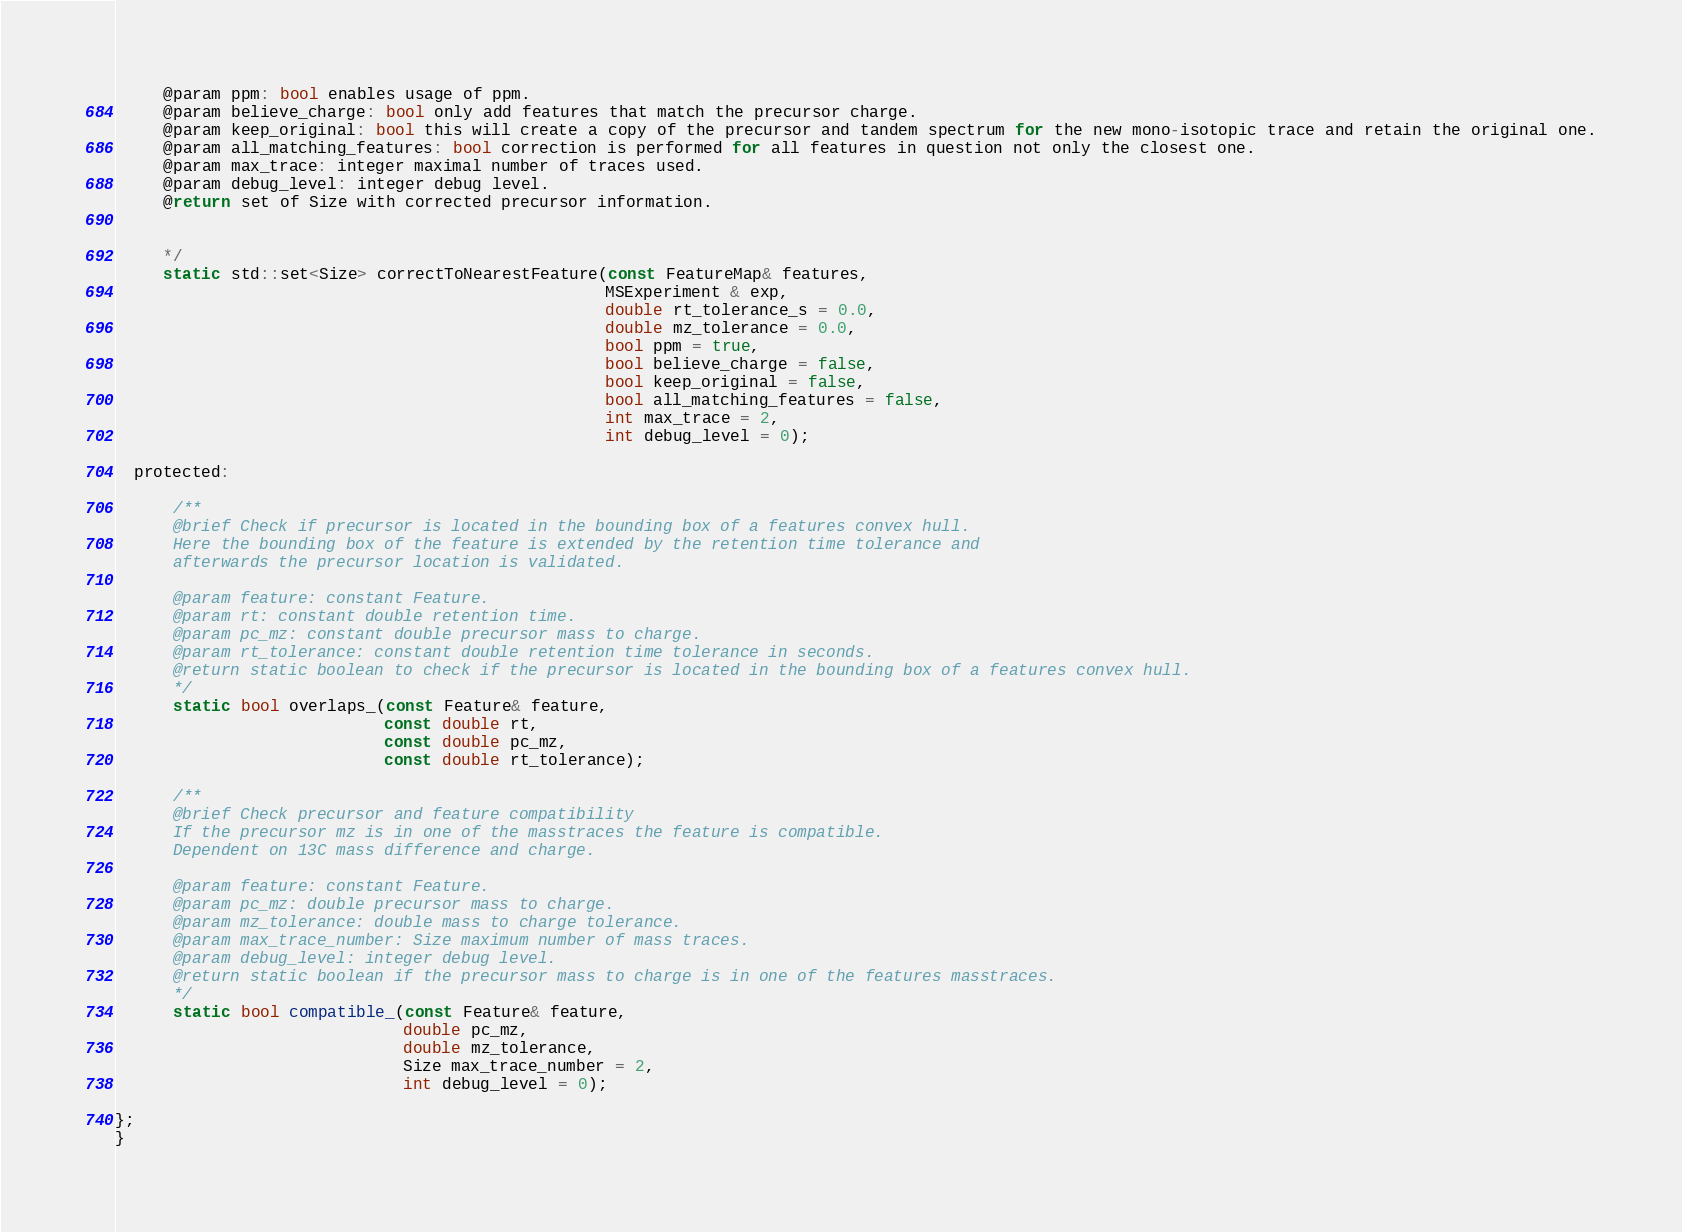<code> <loc_0><loc_0><loc_500><loc_500><_C_>     @param ppm: bool enables usage of ppm.
     @param believe_charge: bool only add features that match the precursor charge.
     @param keep_original: bool this will create a copy of the precursor and tandem spectrum for the new mono-isotopic trace and retain the original one.
     @param all_matching_features: bool correction is performed for all features in question not only the closest one.
     @param max_trace: integer maximal number of traces used.
     @param debug_level: integer debug level.
     @return set of Size with corrected precursor information.


     */
     static std::set<Size> correctToNearestFeature(const FeatureMap& features,
                                                   MSExperiment & exp,
                                                   double rt_tolerance_s = 0.0,
                                                   double mz_tolerance = 0.0,
                                                   bool ppm = true,
                                                   bool believe_charge = false,
                                                   bool keep_original = false,
                                                   bool all_matching_features = false,
                                                   int max_trace = 2,
                                                   int debug_level = 0);

  protected:

      /**
      @brief Check if precursor is located in the bounding box of a features convex hull.
      Here the bounding box of the feature is extended by the retention time tolerance and
      afterwards the precursor location is validated.

      @param feature: constant Feature.
      @param rt: constant double retention time.
      @param pc_mz: constant double precursor mass to charge.
      @param rt_tolerance: constant double retention time tolerance in seconds.
      @return static boolean to check if the precursor is located in the bounding box of a features convex hull.
      */
      static bool overlaps_(const Feature& feature,
                            const double rt,
                            const double pc_mz,
                            const double rt_tolerance);

      /**
      @brief Check precursor and feature compatibility
      If the precursor mz is in one of the masstraces the feature is compatible.
      Dependent on 13C mass difference and charge.

      @param feature: constant Feature.
      @param pc_mz: double precursor mass to charge.
      @param mz_tolerance: double mass to charge tolerance.
      @param max_trace_number: Size maximum number of mass traces.
      @param debug_level: integer debug level.
      @return static boolean if the precursor mass to charge is in one of the features masstraces.
      */
      static bool compatible_(const Feature& feature,
                              double pc_mz,
                              double mz_tolerance,
                              Size max_trace_number = 2,
                              int debug_level = 0);

};
}
</code> 